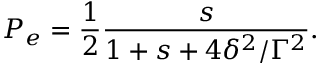<formula> <loc_0><loc_0><loc_500><loc_500>P _ { e } = \frac { 1 } { 2 } \frac { s } { 1 + s + 4 \delta ^ { 2 } / \Gamma ^ { 2 } } .</formula> 